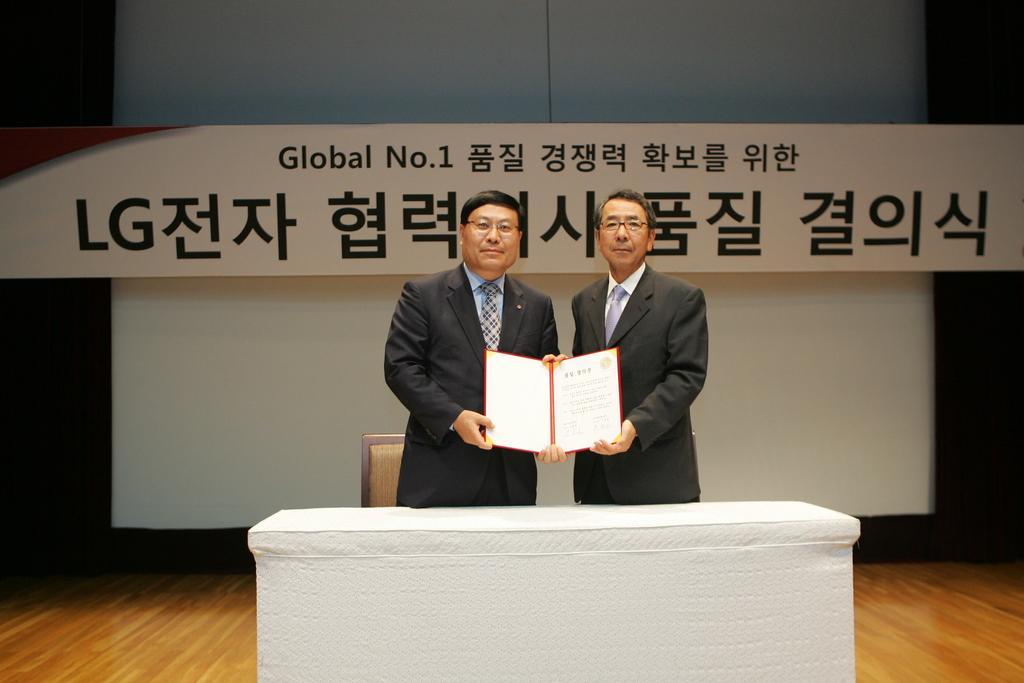Could you give a brief overview of what you see in this image? In this image we can see two men are standing at the table and holding an object in their hands. In the background we can see chair, floor, texts written on a board and an object. 